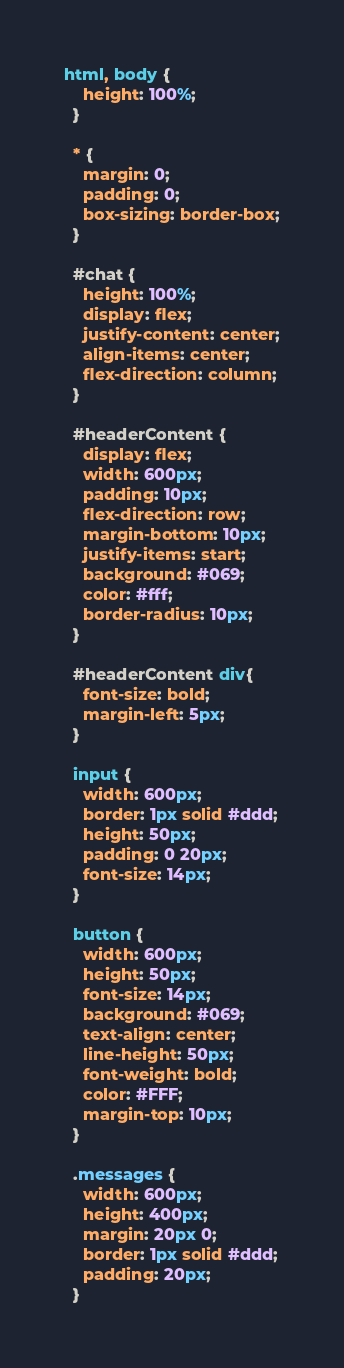Convert code to text. <code><loc_0><loc_0><loc_500><loc_500><_CSS_>html, body {
    height: 100%;
  }
  
  * {
    margin: 0;
    padding: 0;
    box-sizing: border-box;
  }
  
  #chat {
    height: 100%;
    display: flex;
    justify-content: center;
    align-items: center;
    flex-direction: column;
  }

  #headerContent {
    display: flex;
    width: 600px;
    padding: 10px;
    flex-direction: row;
    margin-bottom: 10px;
    justify-items: start;
    background: #069;
    color: #fff;
    border-radius: 10px;
  }

  #headerContent div{
    font-size: bold;
    margin-left: 5px;
  }
  
  input {
    width: 600px;
    border: 1px solid #ddd;
    height: 50px;
    padding: 0 20px;
    font-size: 14px;
  }
  
  button {
    width: 600px;
    height: 50px;
    font-size: 14px;
    background: #069;
    text-align: center;
    line-height: 50px;
    font-weight: bold;
    color: #FFF;
    margin-top: 10px;
  }
  
  .messages {
    width: 600px;
    height: 400px;
    margin: 20px 0;
    border: 1px solid #ddd;
    padding: 20px;
  }</code> 